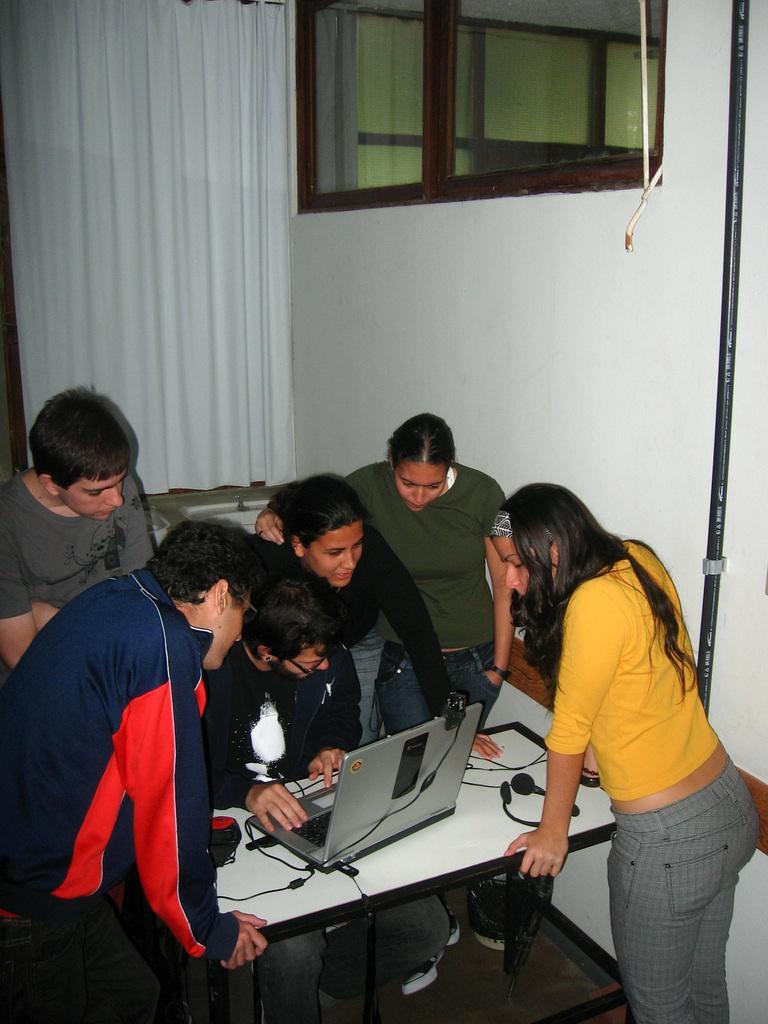How would you summarize this image in a sentence or two? In this picture there are group of people who are standing and looking into the laptop. There is a man who is wearing a black t shirt is sitting on the chair. There is a white curtain at the background. There is a back road to the right. 